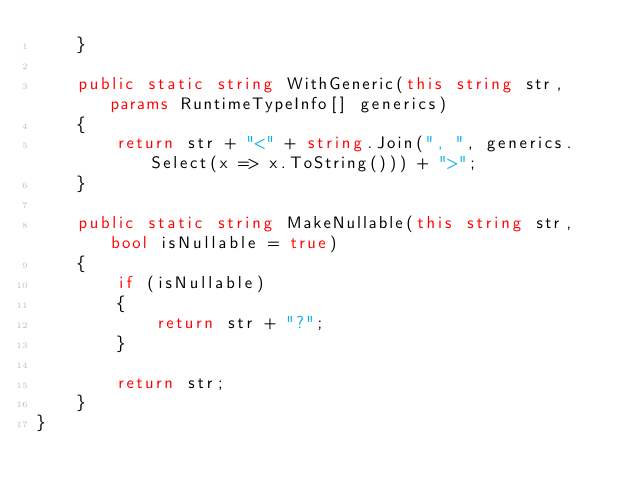Convert code to text. <code><loc_0><loc_0><loc_500><loc_500><_C#_>    }

    public static string WithGeneric(this string str, params RuntimeTypeInfo[] generics)
    {
        return str + "<" + string.Join(", ", generics.Select(x => x.ToString())) + ">";
    }

    public static string MakeNullable(this string str, bool isNullable = true)
    {
        if (isNullable)
        {
            return str + "?";
        }

        return str;
    }
}</code> 